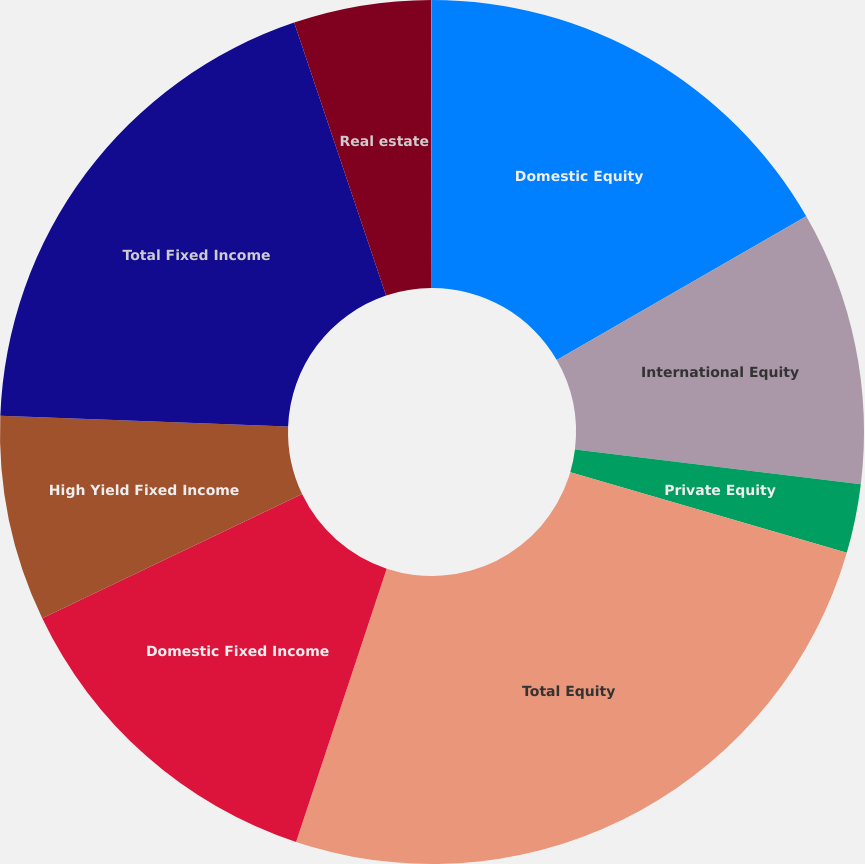Convert chart to OTSL. <chart><loc_0><loc_0><loc_500><loc_500><pie_chart><fcel>Domestic Equity<fcel>International Equity<fcel>Private Equity<fcel>Total Equity<fcel>Domestic Fixed Income<fcel>High Yield Fixed Income<fcel>Total Fixed Income<fcel>Real estate<fcel>Other<nl><fcel>16.68%<fcel>10.25%<fcel>2.58%<fcel>25.59%<fcel>12.81%<fcel>7.7%<fcel>19.23%<fcel>5.14%<fcel>0.03%<nl></chart> 